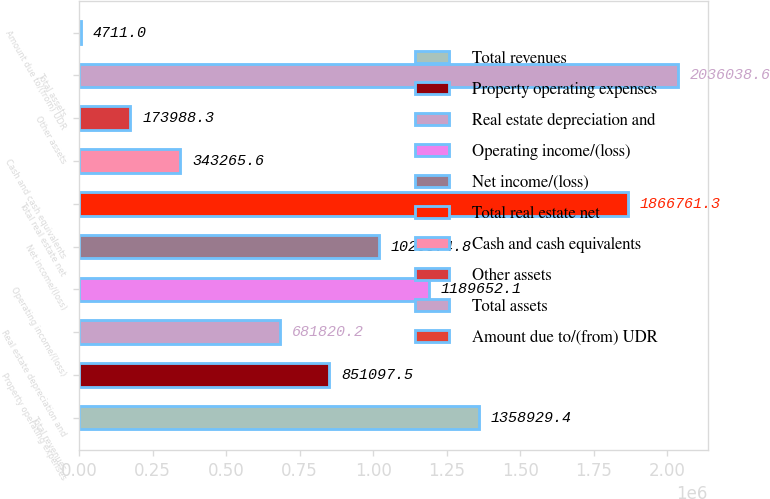Convert chart to OTSL. <chart><loc_0><loc_0><loc_500><loc_500><bar_chart><fcel>Total revenues<fcel>Property operating expenses<fcel>Real estate depreciation and<fcel>Operating income/(loss)<fcel>Net income/(loss)<fcel>Total real estate net<fcel>Cash and cash equivalents<fcel>Other assets<fcel>Total assets<fcel>Amount due to/(from) UDR<nl><fcel>1.35893e+06<fcel>851098<fcel>681820<fcel>1.18965e+06<fcel>1.02037e+06<fcel>1.86676e+06<fcel>343266<fcel>173988<fcel>2.03604e+06<fcel>4711<nl></chart> 